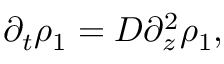<formula> <loc_0><loc_0><loc_500><loc_500>\partial _ { t } \rho _ { 1 } = D \partial _ { z } ^ { 2 } \rho _ { 1 } ,</formula> 